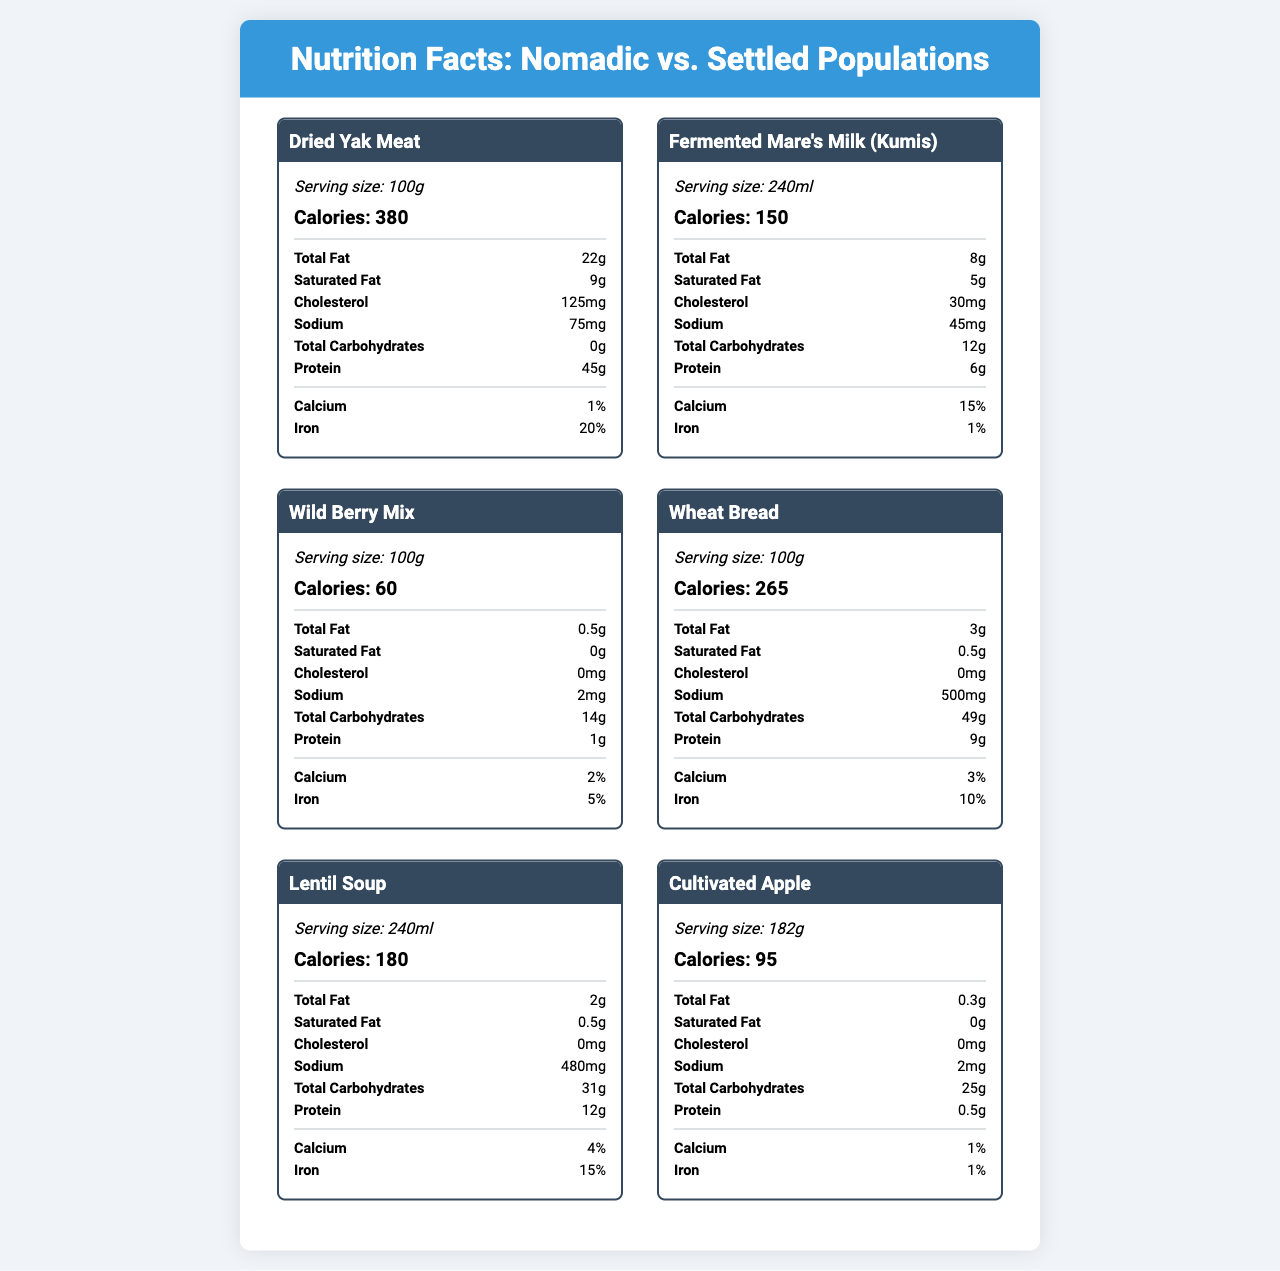which food has the highest protein content per 100g? Dried Yak Meat has 45g of protein per 100g, which is the highest compared to the other foods listed.
Answer: Dried Yak Meat what is the total fat content in Fermented Mare's Milk (Kumis)? According to the document, Fermented Mare's Milk (Kumis) contains 8g of total fat.
Answer: 8g how many calories are in a 240ml serving of Lentil Soup? The document states that a 240ml serving of Lentil Soup contains 180 calories.
Answer: 180 which food item contains the most iron? Dried Yak Meat contains 20% iron, which is the highest among all the listed foods.
Answer: Dried Yak Meat what is the serving size of the Cultivated Apple? The serving size for the Cultivated Apple is listed as 182g.
Answer: 182g which foods contain no cholesterol? A. Wheat Bread B. Lentil Soup C. Cultivated Apple D. All of the above Both Wheat Bread, Lentil Soup, and Cultivated Apple have 0mg of cholesterol.
Answer: D. All of the above which food item has the highest sodium content? A. Dried Yak Meat B. Lentil Soup C. Wild Berry Mix D. Wheat Bread Wheat Bread has 500mg of sodium, which is the highest among all the food items listed.
Answer: D. Wheat Bread do any of the foods have more than 50g of carbohydrates per serving? None of the foods listed have more than 50g of carbohydrates per serving.
Answer: No describe the main idea of the document in one or two sentences. The document's primary goal is to illustrate the nutritional differences between foods consumed by nomadic and settled populations through detailed nutritional facts labels and suggested visualizations.
Answer: The document provides a comparison of the nutritional content of foods consumed by nomadic and settled populations, along with suggested visualizations to represent macronutrient distribution, caloric density, and micronutrient profiles. It showcases differences in protein, fat, carbohydrates, and micronutrient content between the two dietary patterns. how does the caloric density of Nomadic foods compare to Settled foods? The data insights section indicates that Nomadic foods tend to have higher caloric density, likely due to the need for energy-rich, portable nutrition during migrations. Moreover, foods like Dried Yak Meat and Fermented Mare's Milk are calorie-dense.
Answer: Nomadic foods generally have higher caloric density. what was the primary factor affecting the micronutrient variability in nomadic diets? According to the data insights, nomadic diets may have seasonal variations in micronutrient profiles due to the reliance on available natural resources.
Answer: Seasonal variations do all Nomadic foods contain protein? All the listed Nomadic foods (Dried Yak Meat, Fermented Mare's Milk, Wild Berry Mix) have some amount of protein.
Answer: Yes how many foods have more than 10g of total fat per serving? Dried Yak Meat (22g) and Fermented Mare's Milk (8g) together make up the foods with more than 10g of fat.
Answer: Two what is the visual recommendation for showing protein content analysis? The document suggests creating an interactive bar chart that allows users to sort foods by protein content or toggle between nomadic and settled categories.
Answer: Interactive bar chart which nutrient profile is more consistent, nomadic or settled? The data insights state that settled populations' diets show more consistent micronutrient profiles due to diverse food sources.
Answer: Settled is wheat bread richer in protein compared to the Wild Berry Mix? Wheat Bread contains 9g of protein per 100g, whereas Wild Berry Mix has only 1g of protein per 100g.
Answer: Yes which food has the highest percentage of calcium? A. Wild Berry Mix B. Fermented Mare's Milk C. Cultivated Apple Fermented Mare's Milk has a 15% calcium content, which is higher than Wild Berry Mix (2%) and Cultivated Apple (1%).
Answer: B. Fermented Mare's Milk why are nomadic foods generally higher in caloric density? The data insights suggest that nomadic foods are more caloric dense to meet the energy requirements of nomadic lifestyles, which often involve long travel and limited access to food.
Answer: Likely due to the need for energy-rich, portable nutrition during migrations what is the major difference in the nutrient profile between Nomadic and Settled populations? The document highlights that nomadic foods have higher caloric and protein content due to reliance on animal sources, whereas settled diets consist of a more varied diet, leading to consistent micronutrient profiles.
Answer: Nomadic diets have higher caloric and protein content, while settled diets have more consistent micronutrient levels. how many foods have calcium content of 1% or less? Cultivated Apple and Dried Yak Meat both have calcium content of 1%.
Answer: Two which food category is designed for energy-rich, portable nutrition? The document notes that nomadic foods tend to have higher caloric density to provide energy-rich, portable nutrition needed during migrations.
Answer: Nomadic Population Foods which visualization is suggested to compare macronutrient distribution between nomadic and settled foods? The visualization suggestions section recommends using a stacked bar chart to compare macronutrient distribution between nomadic and settled foods.
Answer: Stacked Bar Chart what is the iron content in Wild Berry Mix? The Wild Berry Mix has an iron content of 5%.
Answer: 5% what visualization is recommended to show the seasonal micronutrient levels for both population types? The data insights section suggests developing a dynamic line graph to show micronutrient levels across different seasons for both population types.
Answer: Dynamic line graph can you determine how long these food items can be stored based on the document? The document provides nutritional information and visualization suggestions but does not contain details on the storage duration of these food items.
Answer: Not enough information 